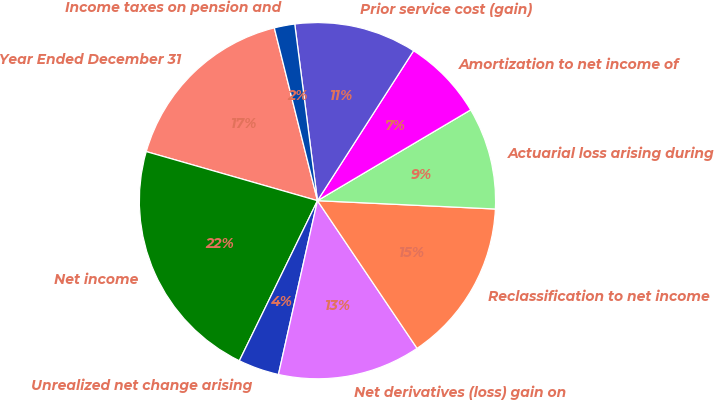Convert chart. <chart><loc_0><loc_0><loc_500><loc_500><pie_chart><fcel>Year Ended December 31<fcel>Net income<fcel>Unrealized net change arising<fcel>Net derivatives (loss) gain on<fcel>Reclassification to net income<fcel>Actuarial loss arising during<fcel>Amortization to net income of<fcel>Prior service cost (gain)<fcel>Income taxes on pension and<nl><fcel>16.66%<fcel>22.22%<fcel>3.71%<fcel>12.96%<fcel>14.81%<fcel>9.26%<fcel>7.41%<fcel>11.11%<fcel>1.86%<nl></chart> 